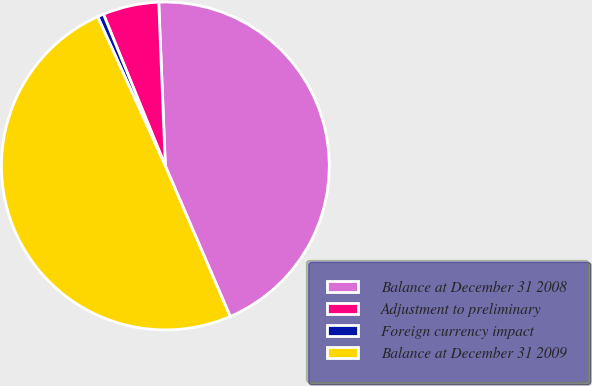Convert chart. <chart><loc_0><loc_0><loc_500><loc_500><pie_chart><fcel>Balance at December 31 2008<fcel>Adjustment to preliminary<fcel>Foreign currency impact<fcel>Balance at December 31 2009<nl><fcel>44.16%<fcel>5.52%<fcel>0.61%<fcel>49.7%<nl></chart> 